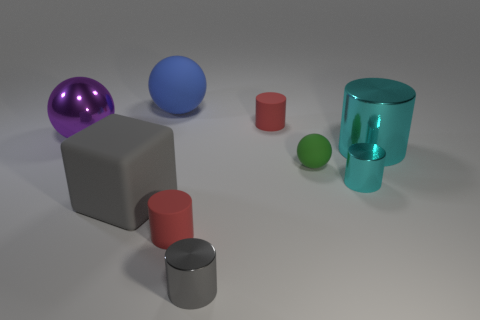Subtract 2 cylinders. How many cylinders are left? 3 Subtract all gray cylinders. How many cylinders are left? 4 Subtract all gray cylinders. How many cylinders are left? 4 Subtract all brown cylinders. Subtract all gray cubes. How many cylinders are left? 5 Subtract all cubes. How many objects are left? 8 Add 3 tiny cyan metal cylinders. How many tiny cyan metal cylinders are left? 4 Add 5 large blue things. How many large blue things exist? 6 Subtract 0 cyan balls. How many objects are left? 9 Subtract all small green metallic cylinders. Subtract all small red matte cylinders. How many objects are left? 7 